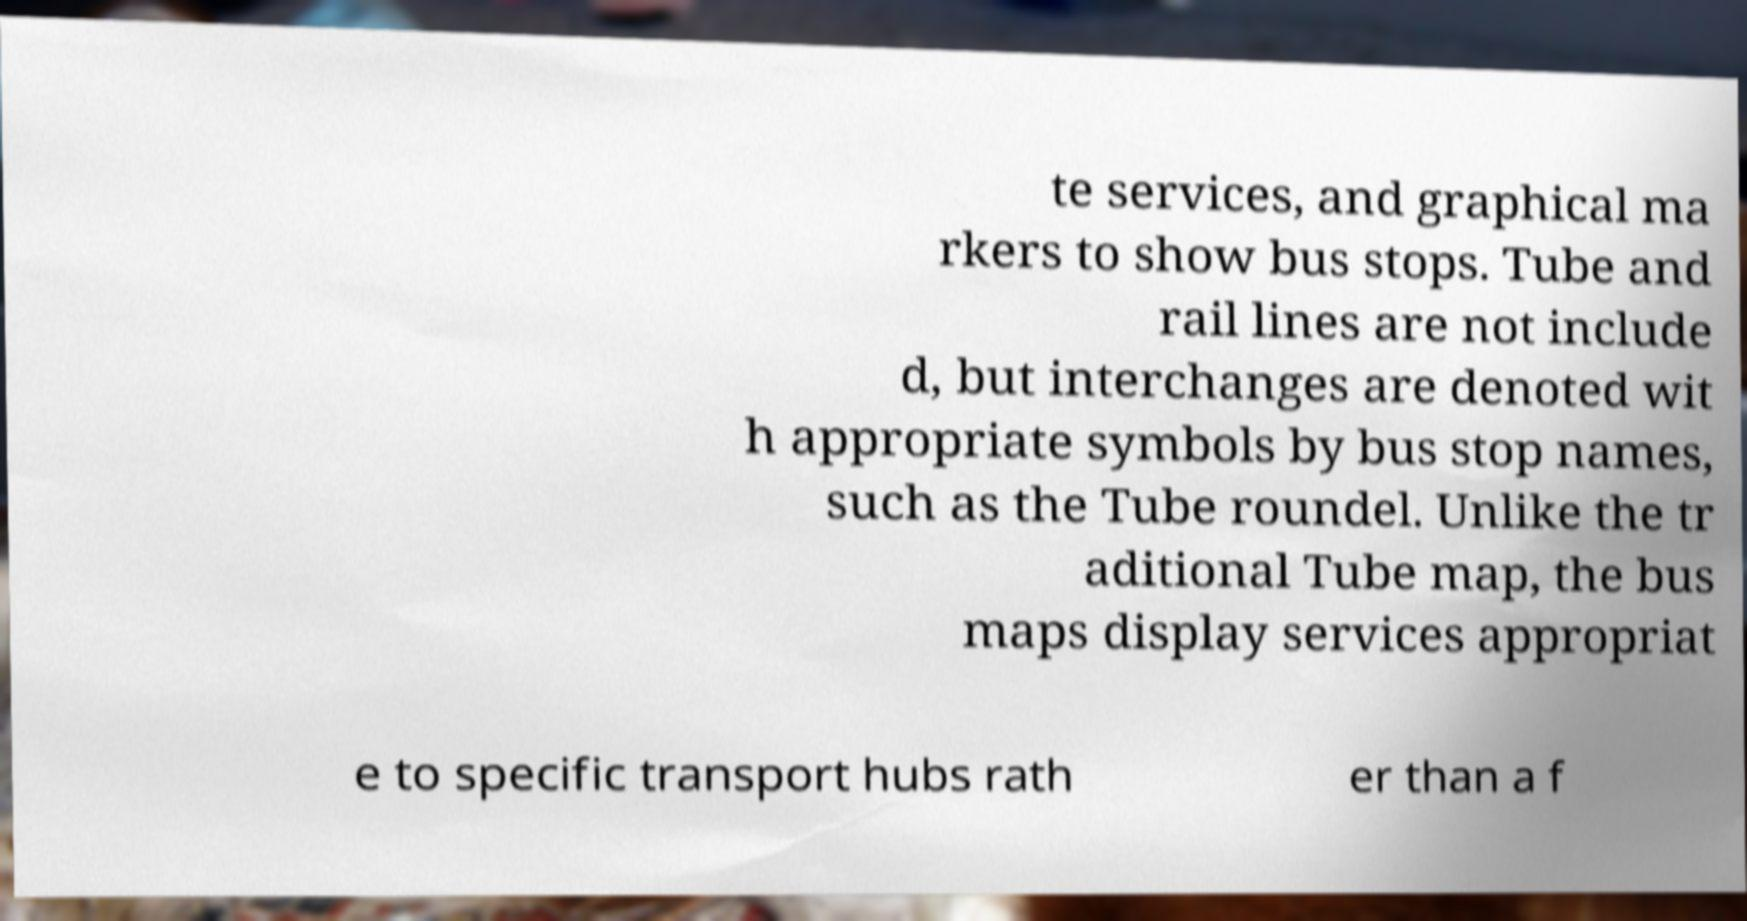I need the written content from this picture converted into text. Can you do that? te services, and graphical ma rkers to show bus stops. Tube and rail lines are not include d, but interchanges are denoted wit h appropriate symbols by bus stop names, such as the Tube roundel. Unlike the tr aditional Tube map, the bus maps display services appropriat e to specific transport hubs rath er than a f 